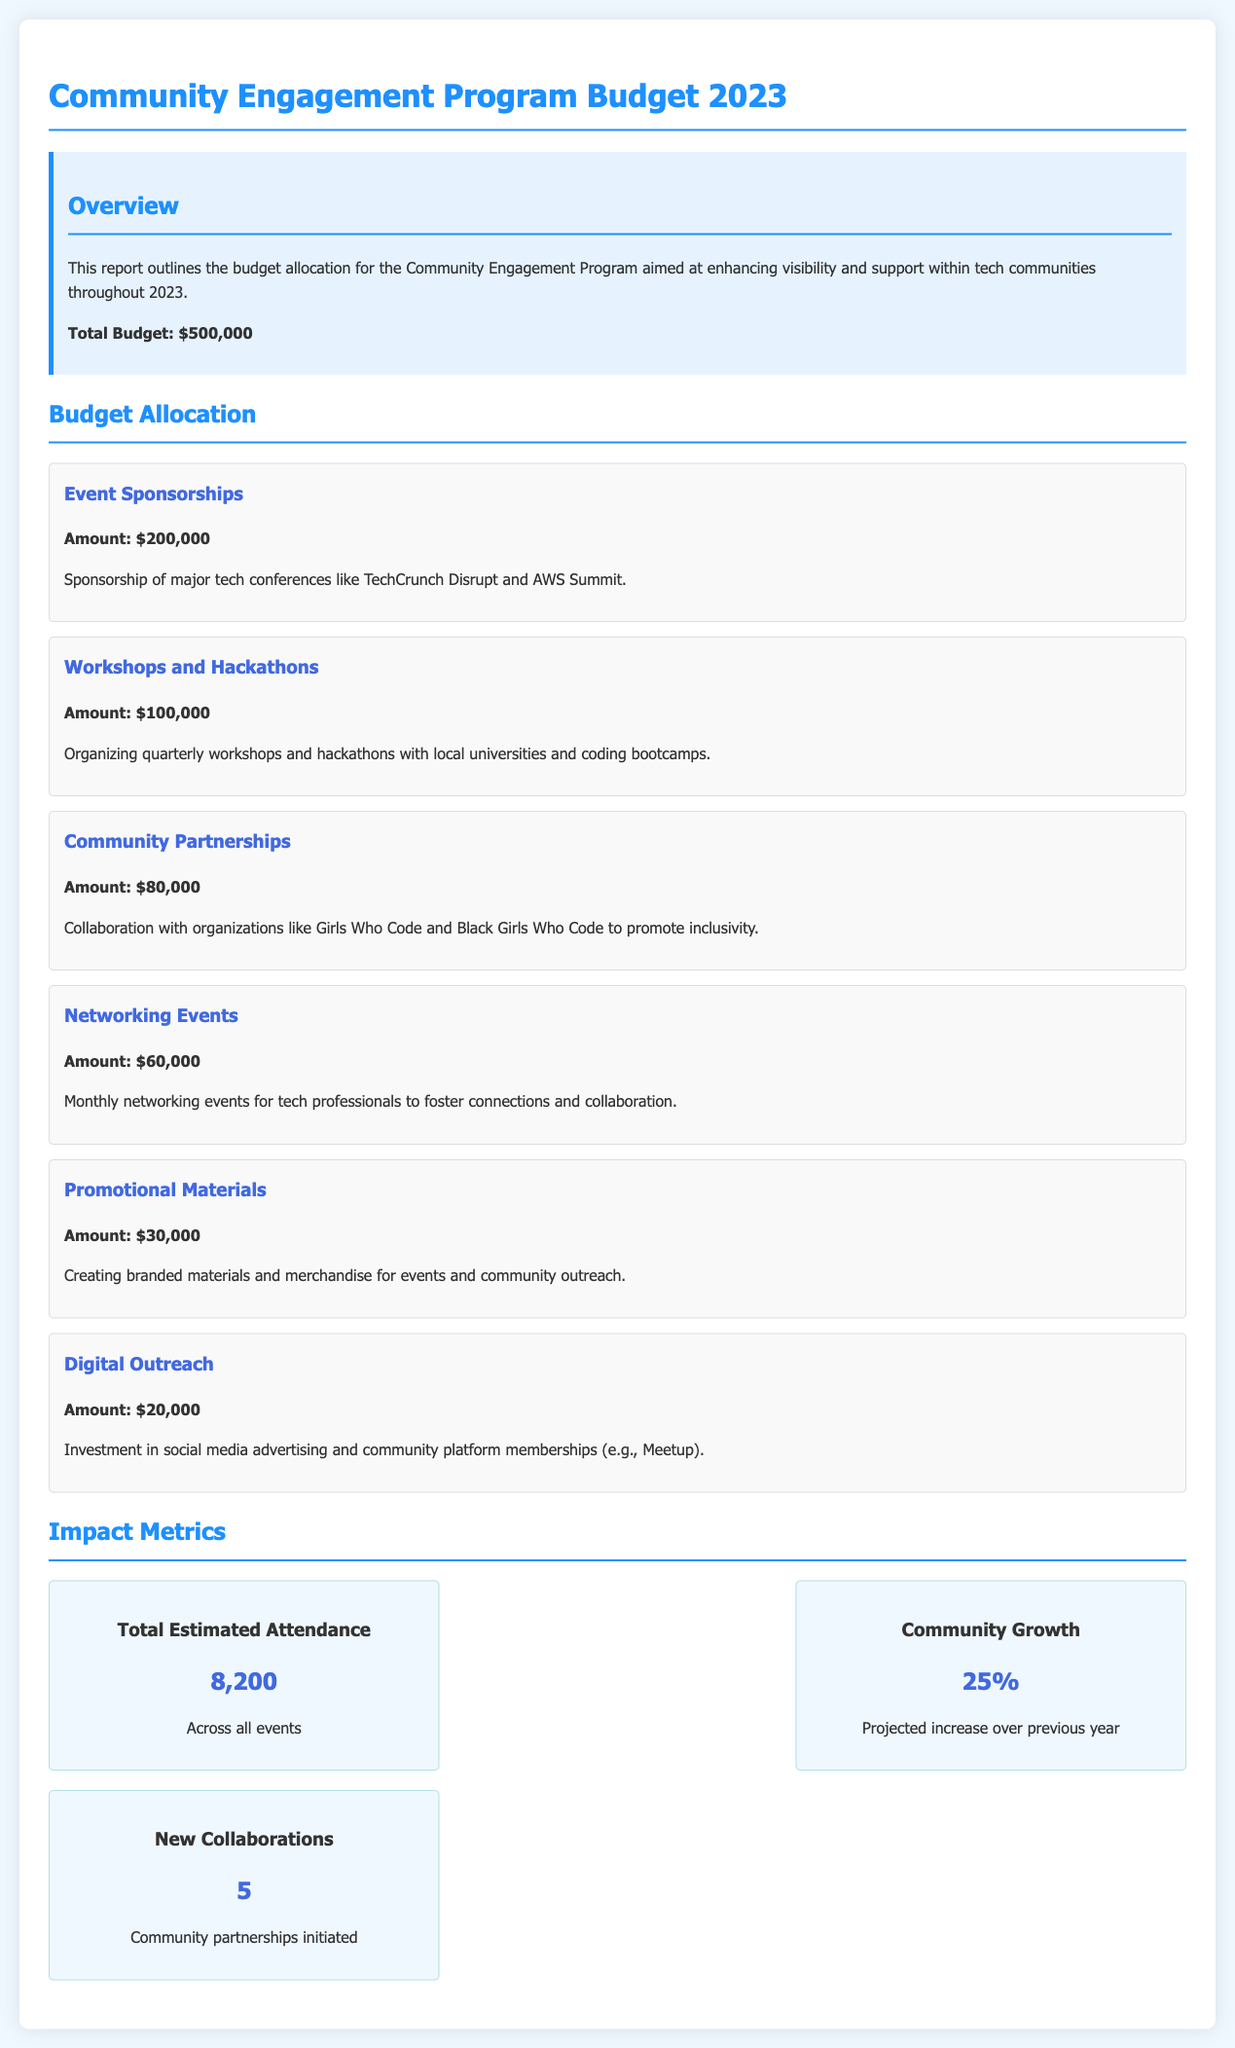What is the total budget for 2023? The total budget is explicitly stated in the document as $500,000.
Answer: $500,000 How much is allocated for Event Sponsorships? The amount allocated for Event Sponsorships is clearly listed in the budget section of the document.
Answer: $200,000 What is the projected community growth percentage? The projected community growth percentage is provided under the impact metrics section.
Answer: 25% How many new collaborations are anticipated? The number of new collaborations is indicated in the impact metrics section of the report.
Answer: 5 What is the budget allocation for Digital Outreach? The budget allocation for Digital Outreach can be found in the budget allocation section.
Answer: $20,000 How many total estimated attendees are expected across all events? The total estimated attendance figure is documented in the impact metrics section.
Answer: 8,200 What organization is mentioned for community partnerships focused on inclusivity? The name of an organization mentioned for community partnerships is included in the budget allocation section.
Answer: Girls Who Code How much funding is dedicated to Networking Events? The funding amount specifically for Networking Events is detailed in the budget allocation section.
Answer: $60,000 